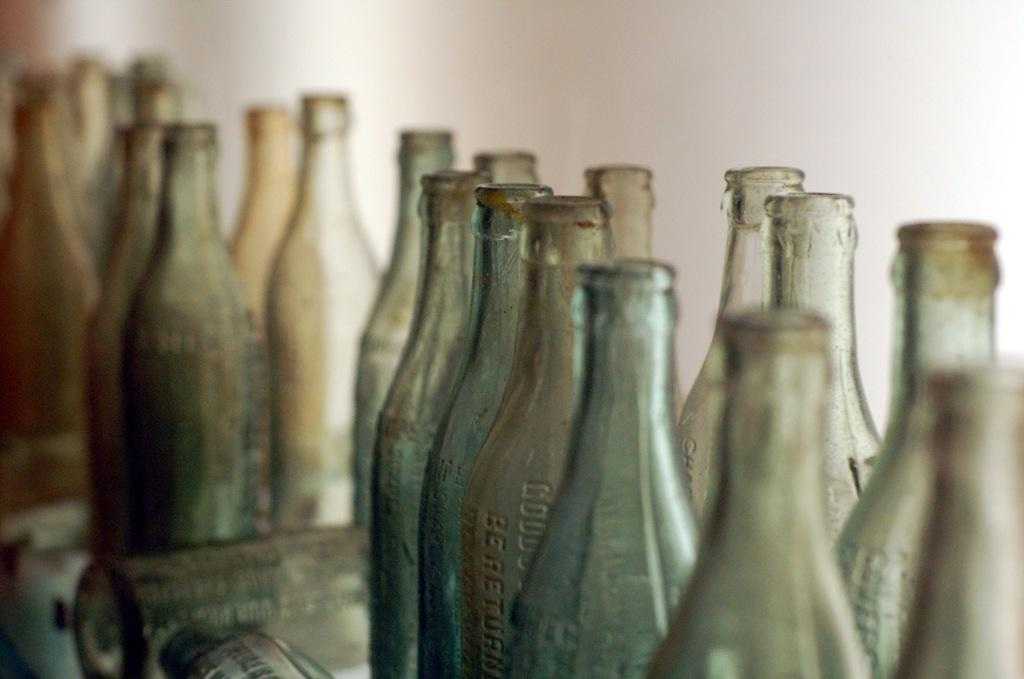What objects are visible in the image? There are many bottles in the image. Where are the bottles located? The bottles are placed on a table. What type of owl can be seen sitting on top of the bottles in the image? There is no owl present in the image; it only features bottles placed on a table. 